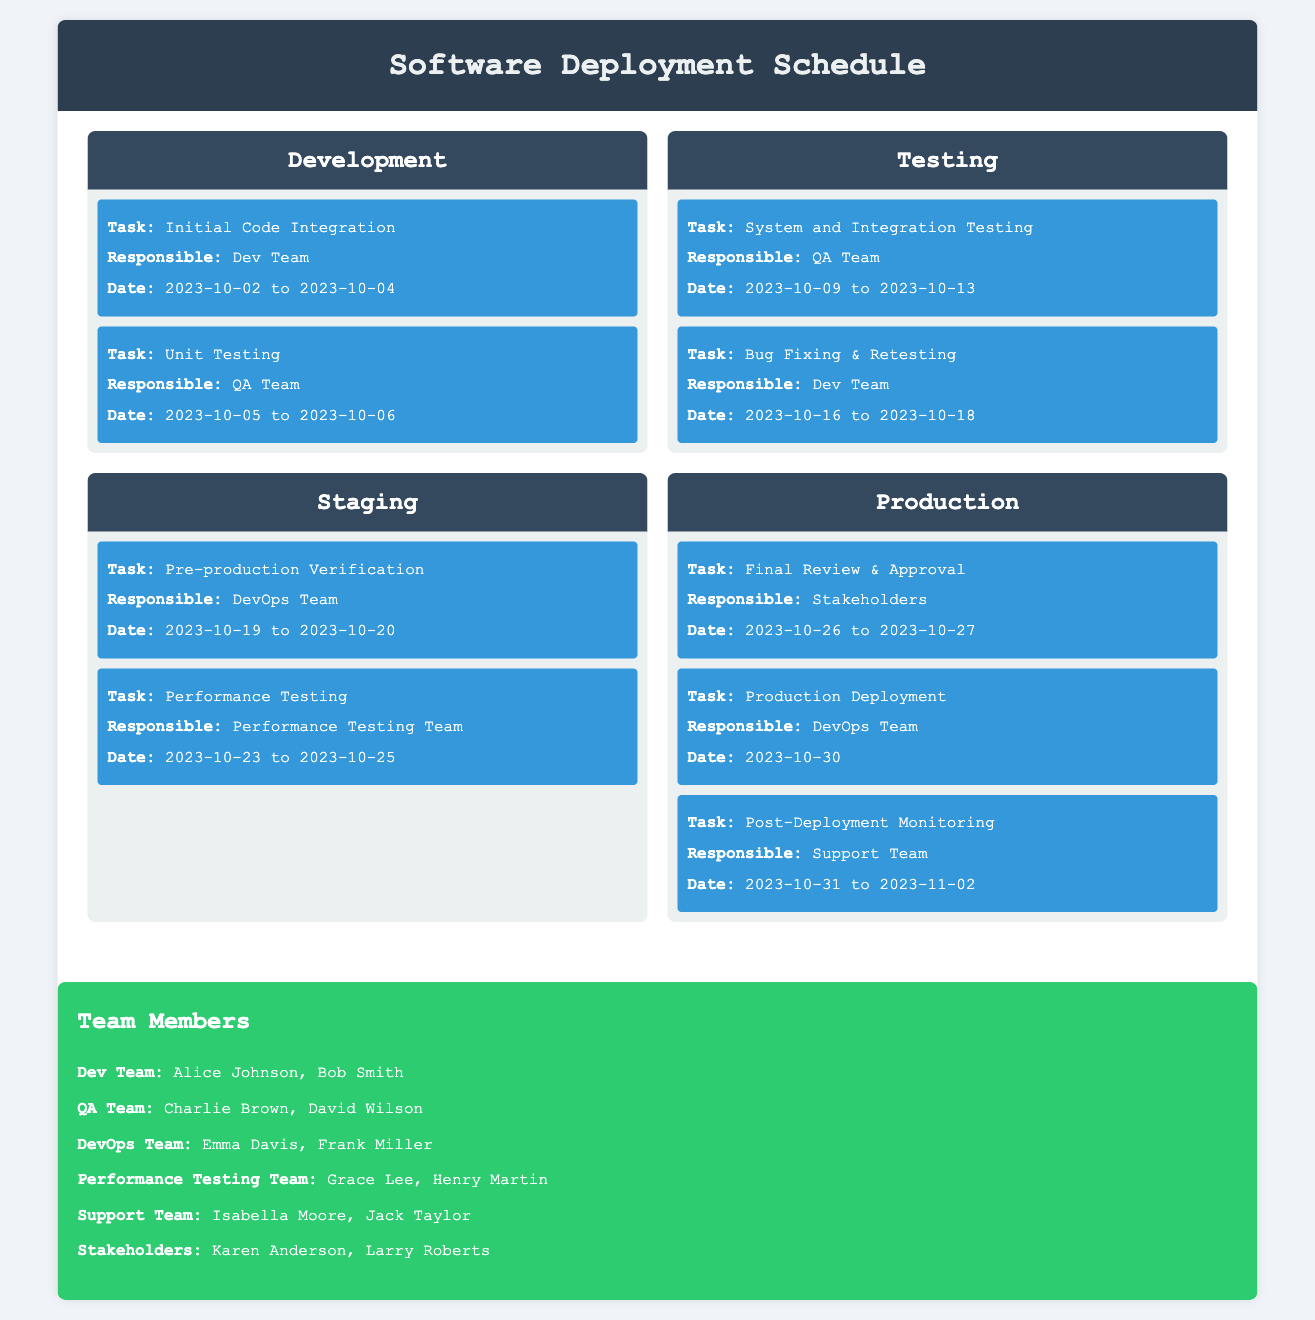what is the first task in the Development environment? The first task listed under the Development environment is "Initial Code Integration."
Answer: Initial Code Integration who is responsible for Unit Testing? The task "Unit Testing" is assigned to the QA Team.
Answer: QA Team what are the dates for System and Integration Testing? The dates for "System and Integration Testing" are from October 9 to October 13, 2023.
Answer: 2023-10-09 to 2023-10-13 which team performs Performance Testing in Staging? The "Performance Testing" task in the Staging environment is handled by the Performance Testing Team.
Answer: Performance Testing Team what is the final task in the Production environment? The last task listed under the Production environment is "Post-Deployment Monitoring."
Answer: Post-Deployment Monitoring how many days is the Pre-production Verification scheduled for? "Pre-production Verification" is scheduled for 2 days, from October 19 to October 20, 2023.
Answer: 2 days who is responsible for the final review and approval? The responsible group for the task "Final Review & Approval" is the Stakeholders.
Answer: Stakeholders what is the date of the Production Deployment? The production deployment is scheduled for October 30, 2023.
Answer: 2023-10-30 how many total team members are listed in the document? There are 6 teams listed, with a total of 12 members.
Answer: 12 members 